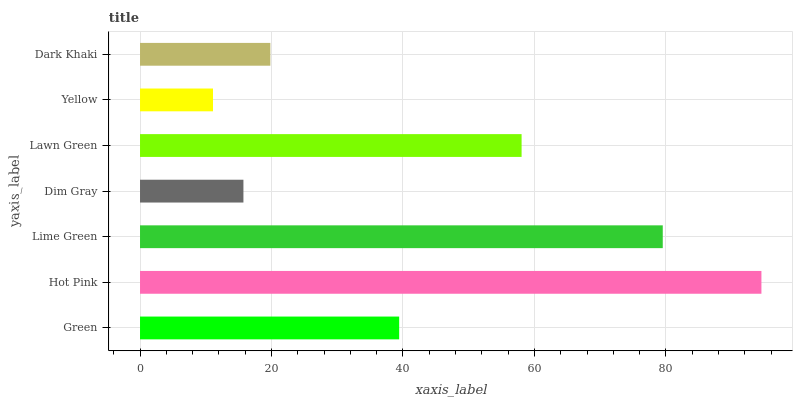Is Yellow the minimum?
Answer yes or no. Yes. Is Hot Pink the maximum?
Answer yes or no. Yes. Is Lime Green the minimum?
Answer yes or no. No. Is Lime Green the maximum?
Answer yes or no. No. Is Hot Pink greater than Lime Green?
Answer yes or no. Yes. Is Lime Green less than Hot Pink?
Answer yes or no. Yes. Is Lime Green greater than Hot Pink?
Answer yes or no. No. Is Hot Pink less than Lime Green?
Answer yes or no. No. Is Green the high median?
Answer yes or no. Yes. Is Green the low median?
Answer yes or no. Yes. Is Lime Green the high median?
Answer yes or no. No. Is Dim Gray the low median?
Answer yes or no. No. 